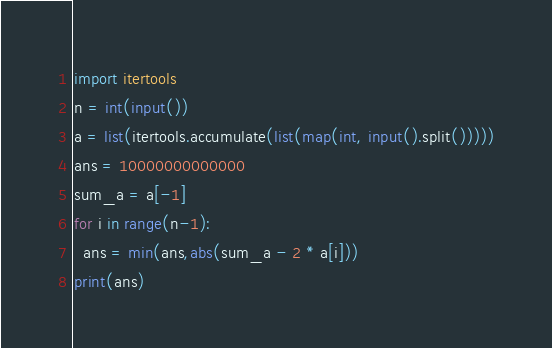<code> <loc_0><loc_0><loc_500><loc_500><_Python_>import itertools
n = int(input())
a = list(itertools.accumulate(list(map(int, input().split()))))
ans = 10000000000000
sum_a = a[-1]
for i in range(n-1):
  ans = min(ans,abs(sum_a - 2 * a[i]))
print(ans)
</code> 